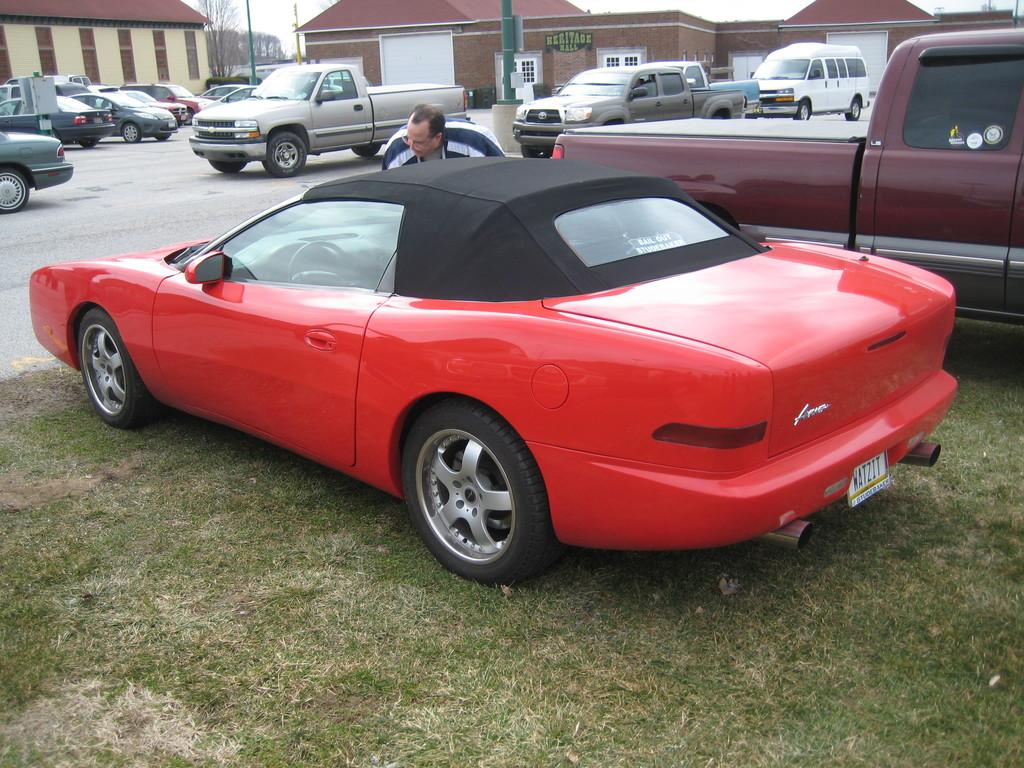What is the main feature of the image? There is a road in the image. What is happening on the road? There are vehicles on the road. Can you describe the people in the image? There is a person in the image. What else can be seen in the image besides the road and vehicles? There is a pole, houses, and a tree in the image. What is visible at the top of the image? The sky is visible at the top of the image. What type of company is represented by the coil in the image? There is no coil present in the image, and therefore no company can be associated with it. What scientific discovery is being made in the image? There is no scientific discovery being made in the image; it depicts a road, vehicles, a person, a pole, houses, a tree, and the sky. 